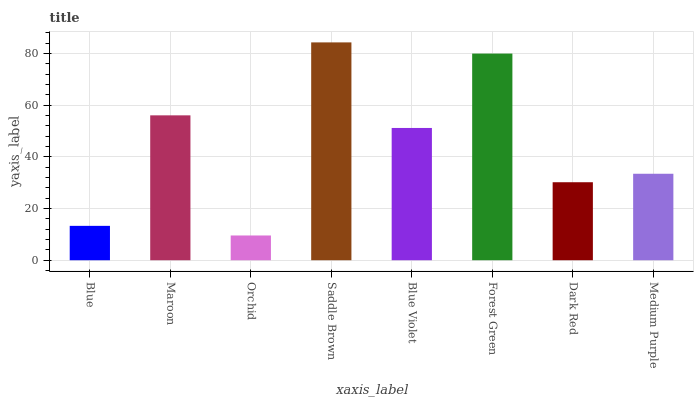Is Maroon the minimum?
Answer yes or no. No. Is Maroon the maximum?
Answer yes or no. No. Is Maroon greater than Blue?
Answer yes or no. Yes. Is Blue less than Maroon?
Answer yes or no. Yes. Is Blue greater than Maroon?
Answer yes or no. No. Is Maroon less than Blue?
Answer yes or no. No. Is Blue Violet the high median?
Answer yes or no. Yes. Is Medium Purple the low median?
Answer yes or no. Yes. Is Saddle Brown the high median?
Answer yes or no. No. Is Blue the low median?
Answer yes or no. No. 